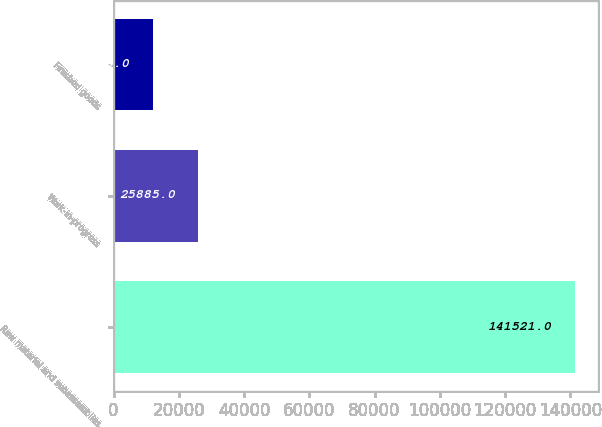<chart> <loc_0><loc_0><loc_500><loc_500><bar_chart><fcel>Raw material and subassemblies<fcel>Work-in-progress<fcel>Finished goods<nl><fcel>141521<fcel>25885<fcel>11960<nl></chart> 